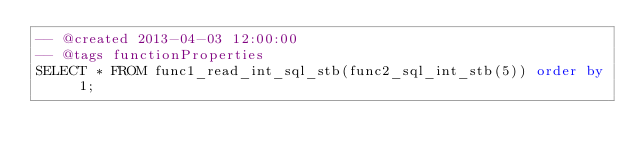Convert code to text. <code><loc_0><loc_0><loc_500><loc_500><_SQL_>-- @created 2013-04-03 12:00:00
-- @tags functionProperties 
SELECT * FROM func1_read_int_sql_stb(func2_sql_int_stb(5)) order by 1; 
</code> 